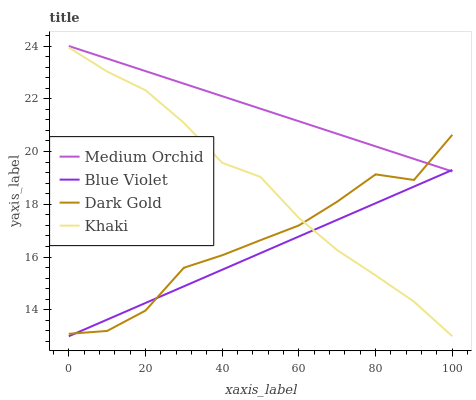Does Blue Violet have the minimum area under the curve?
Answer yes or no. Yes. Does Medium Orchid have the maximum area under the curve?
Answer yes or no. Yes. Does Khaki have the minimum area under the curve?
Answer yes or no. No. Does Khaki have the maximum area under the curve?
Answer yes or no. No. Is Medium Orchid the smoothest?
Answer yes or no. Yes. Is Dark Gold the roughest?
Answer yes or no. Yes. Is Khaki the smoothest?
Answer yes or no. No. Is Khaki the roughest?
Answer yes or no. No. Does Khaki have the lowest value?
Answer yes or no. Yes. Does Dark Gold have the lowest value?
Answer yes or no. No. Does Medium Orchid have the highest value?
Answer yes or no. Yes. Does Khaki have the highest value?
Answer yes or no. No. Is Khaki less than Medium Orchid?
Answer yes or no. Yes. Is Medium Orchid greater than Khaki?
Answer yes or no. Yes. Does Blue Violet intersect Khaki?
Answer yes or no. Yes. Is Blue Violet less than Khaki?
Answer yes or no. No. Is Blue Violet greater than Khaki?
Answer yes or no. No. Does Khaki intersect Medium Orchid?
Answer yes or no. No. 